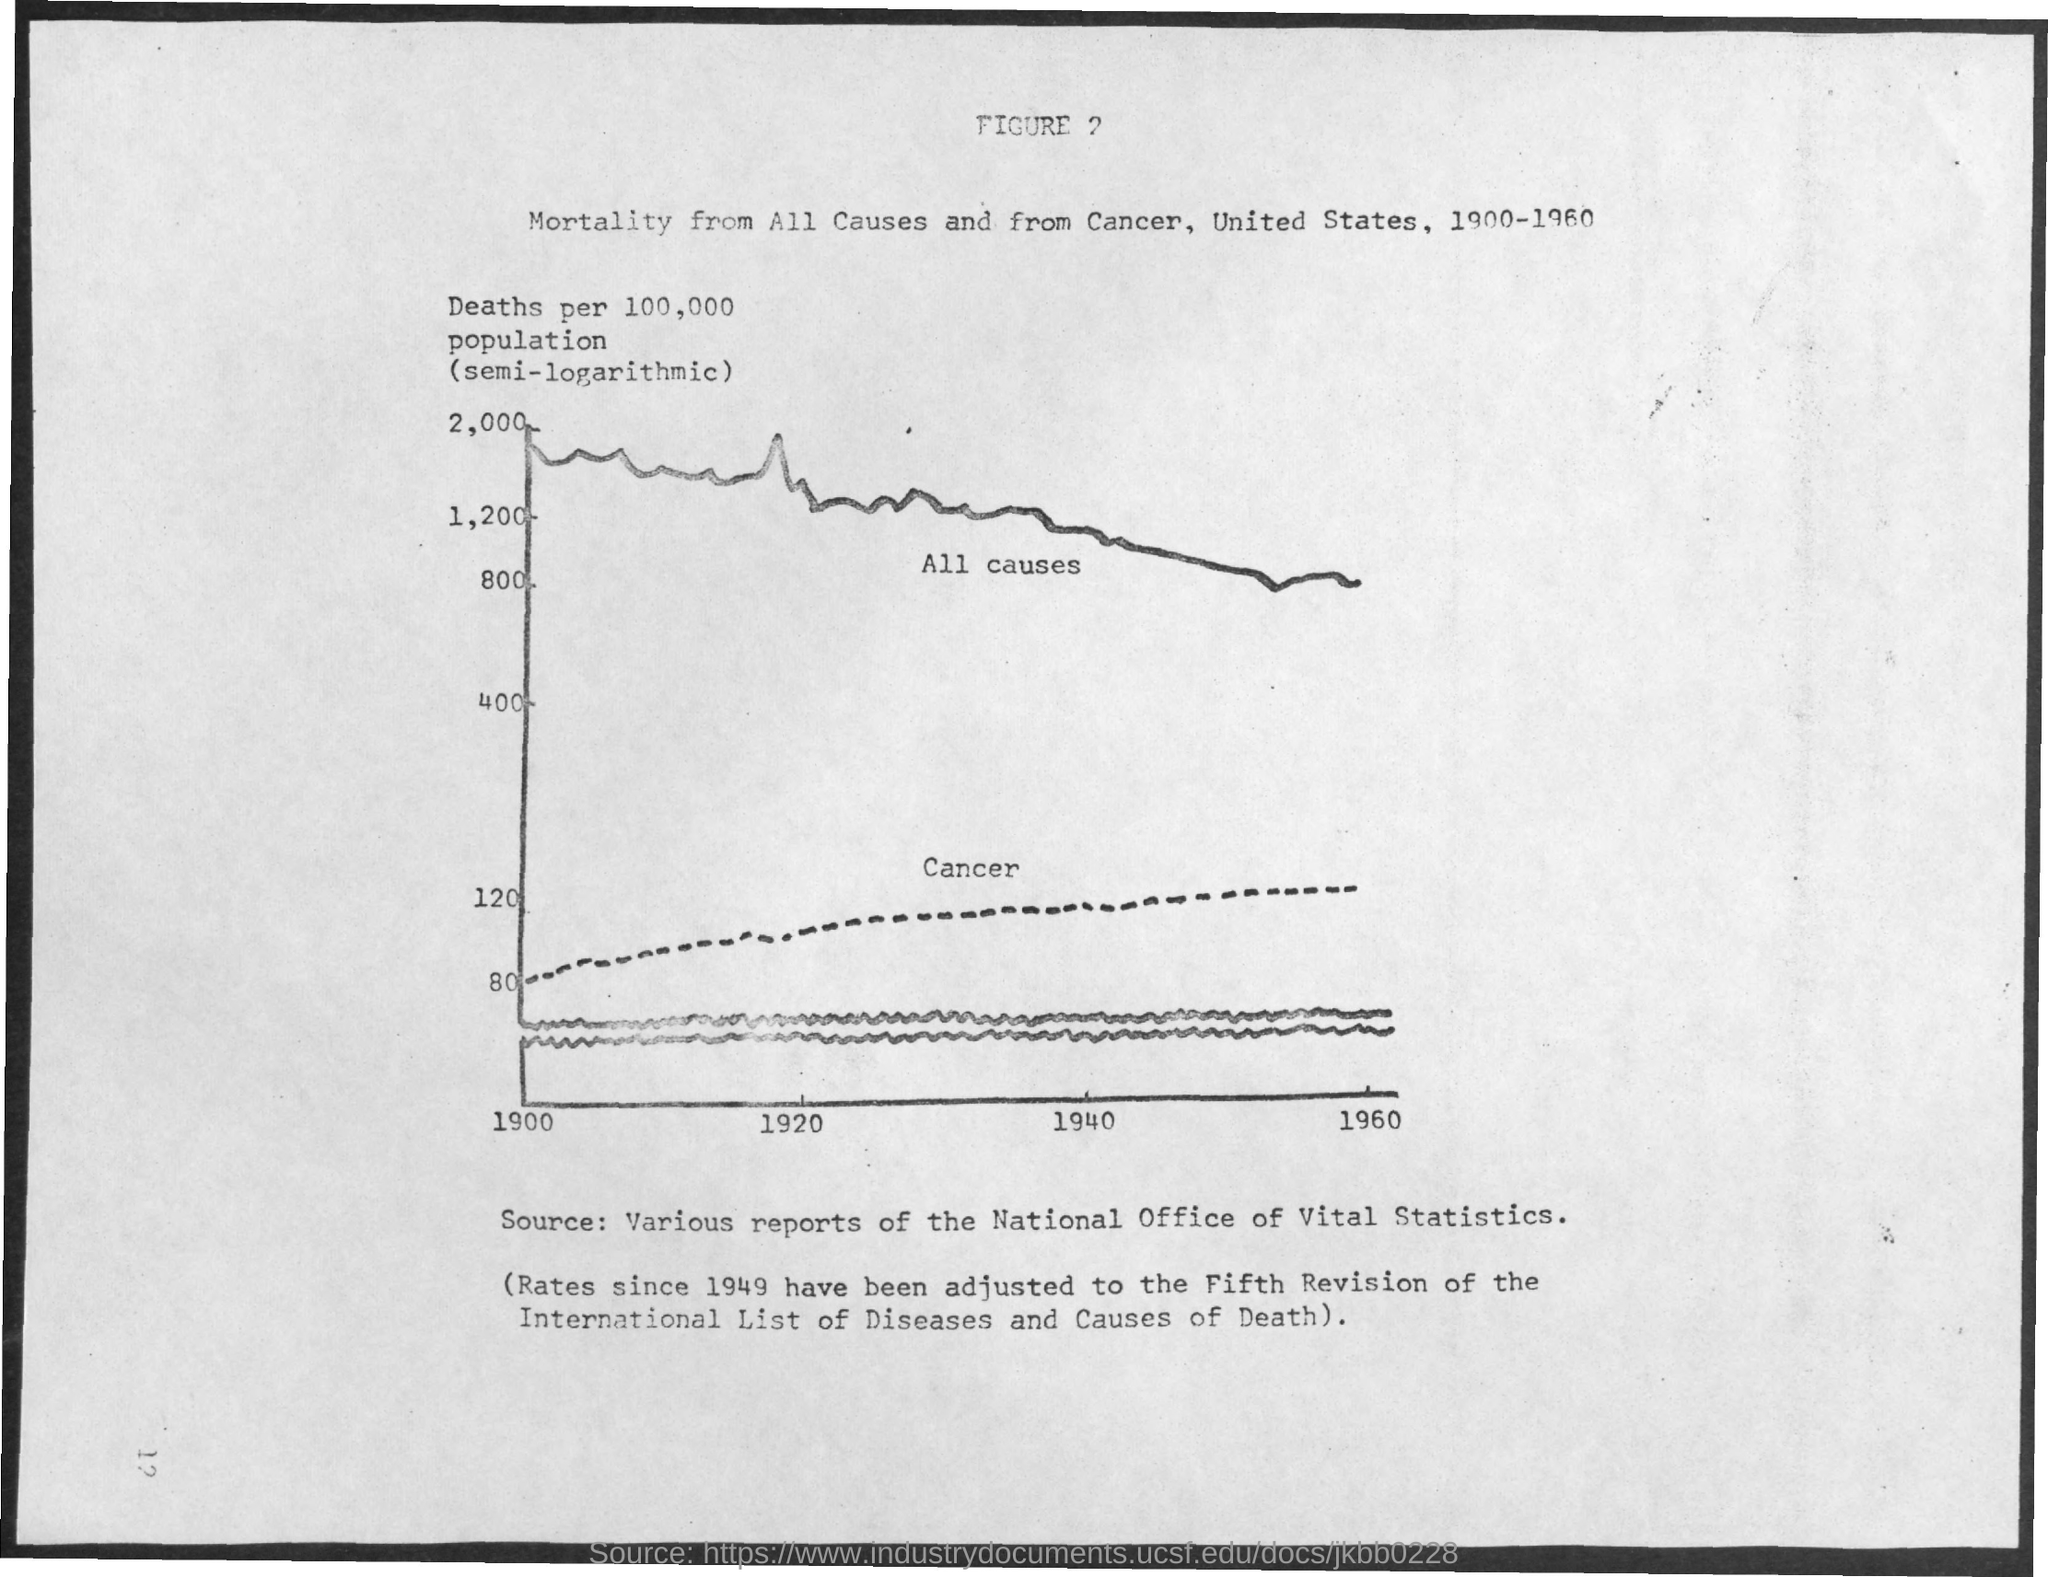The dotted line represents which disease?
Your answer should be compact. Cancer. The bold line represents which disease?
Your answer should be compact. All causes. Which year is plotted first in the x-axis?
Offer a very short reply. 1900. Which year is plotted last in the x-axis?
Offer a very short reply. 1960. Which number is plotted last in the y-axis?
Ensure brevity in your answer.  2,000. 